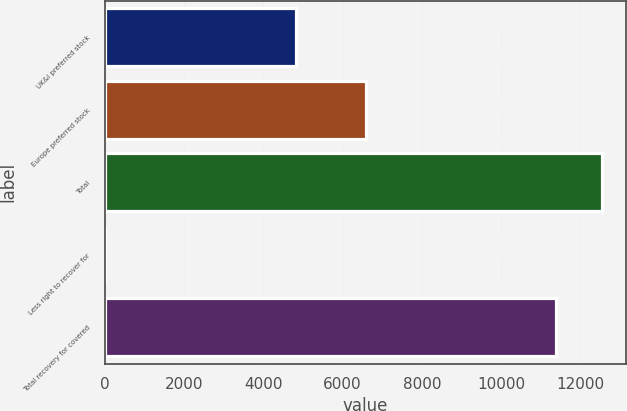Convert chart to OTSL. <chart><loc_0><loc_0><loc_500><loc_500><bar_chart><fcel>UK&I preferred stock<fcel>Europe preferred stock<fcel>Total<fcel>Less right to recover for<fcel>Total recovery for covered<nl><fcel>4823<fcel>6580<fcel>12535.6<fcel>7<fcel>11396<nl></chart> 